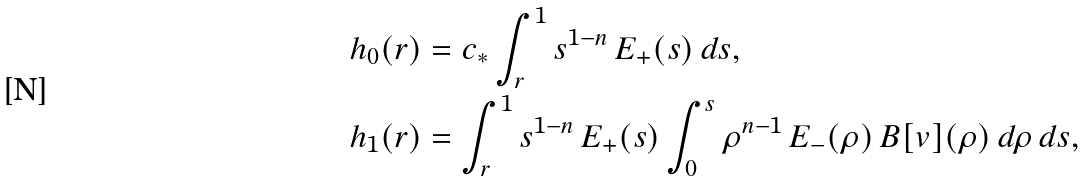Convert formula to latex. <formula><loc_0><loc_0><loc_500><loc_500>h _ { 0 } ( r ) & = c _ { * } \int _ { r } ^ { 1 } s ^ { 1 - n } \, E _ { + } ( s ) \, d s , \\ h _ { 1 } ( r ) & = \int _ { r } ^ { 1 } s ^ { 1 - n } \, E _ { + } ( s ) \int _ { 0 } ^ { s } \rho ^ { n - 1 } \, E _ { - } ( \rho ) \, B [ v ] ( \rho ) \, d \rho \, d s ,</formula> 